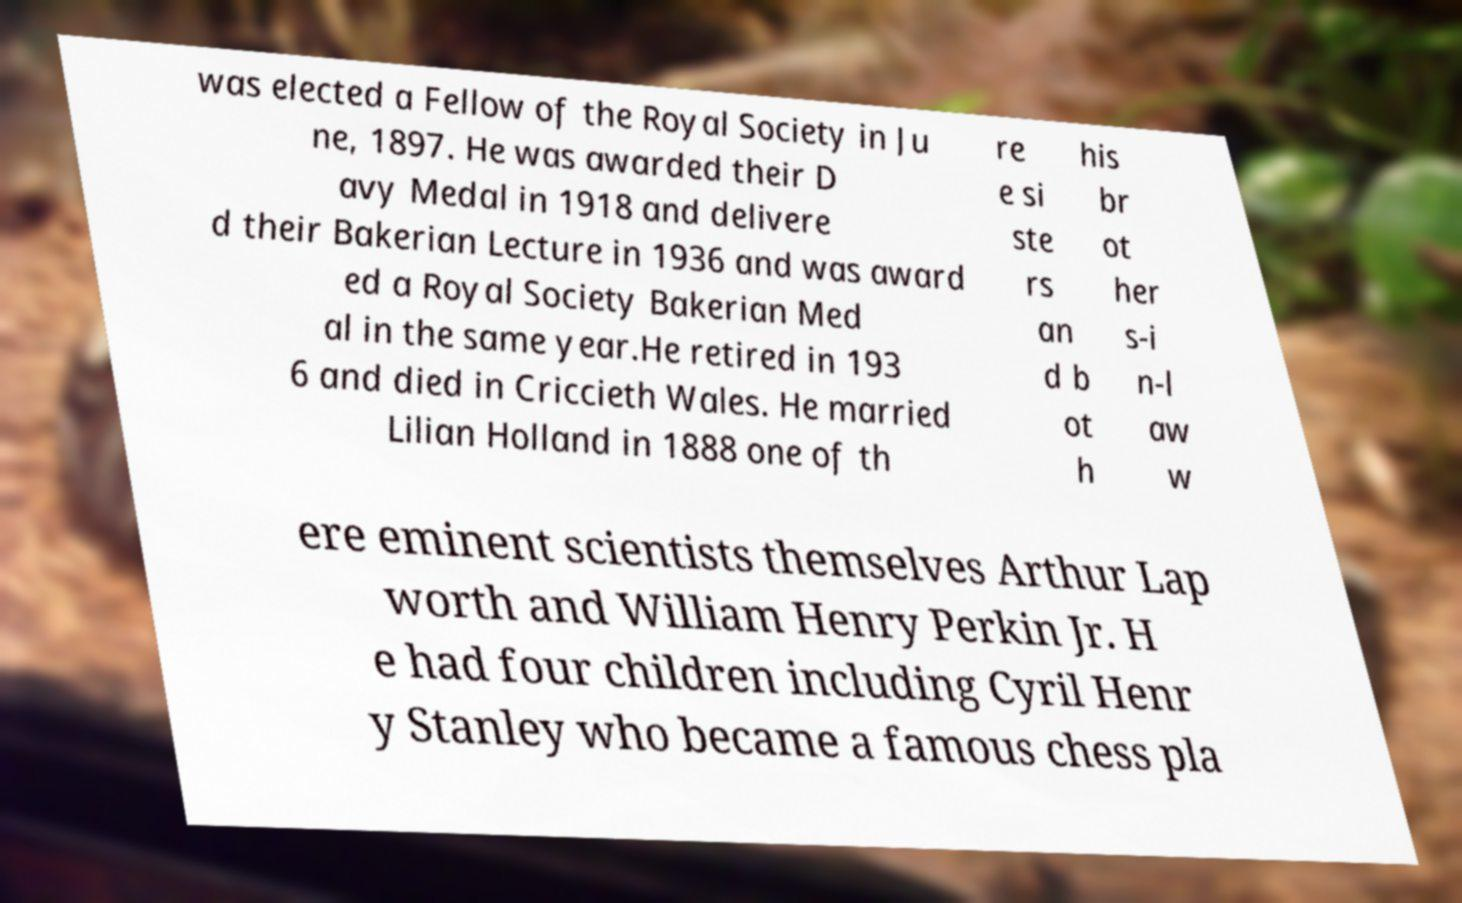Please identify and transcribe the text found in this image. was elected a Fellow of the Royal Society in Ju ne, 1897. He was awarded their D avy Medal in 1918 and delivere d their Bakerian Lecture in 1936 and was award ed a Royal Society Bakerian Med al in the same year.He retired in 193 6 and died in Criccieth Wales. He married Lilian Holland in 1888 one of th re e si ste rs an d b ot h his br ot her s-i n-l aw w ere eminent scientists themselves Arthur Lap worth and William Henry Perkin Jr. H e had four children including Cyril Henr y Stanley who became a famous chess pla 